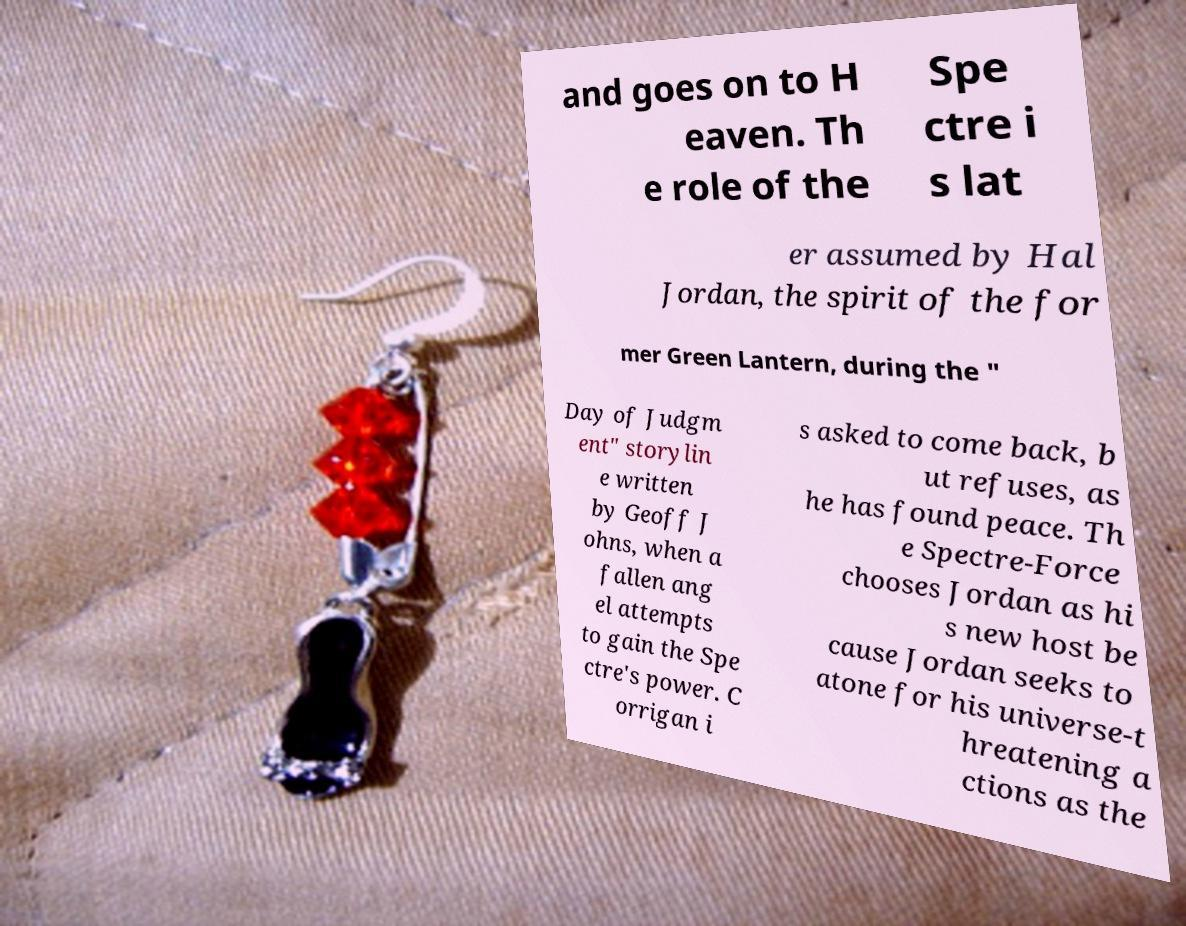For documentation purposes, I need the text within this image transcribed. Could you provide that? and goes on to H eaven. Th e role of the Spe ctre i s lat er assumed by Hal Jordan, the spirit of the for mer Green Lantern, during the " Day of Judgm ent" storylin e written by Geoff J ohns, when a fallen ang el attempts to gain the Spe ctre's power. C orrigan i s asked to come back, b ut refuses, as he has found peace. Th e Spectre-Force chooses Jordan as hi s new host be cause Jordan seeks to atone for his universe-t hreatening a ctions as the 